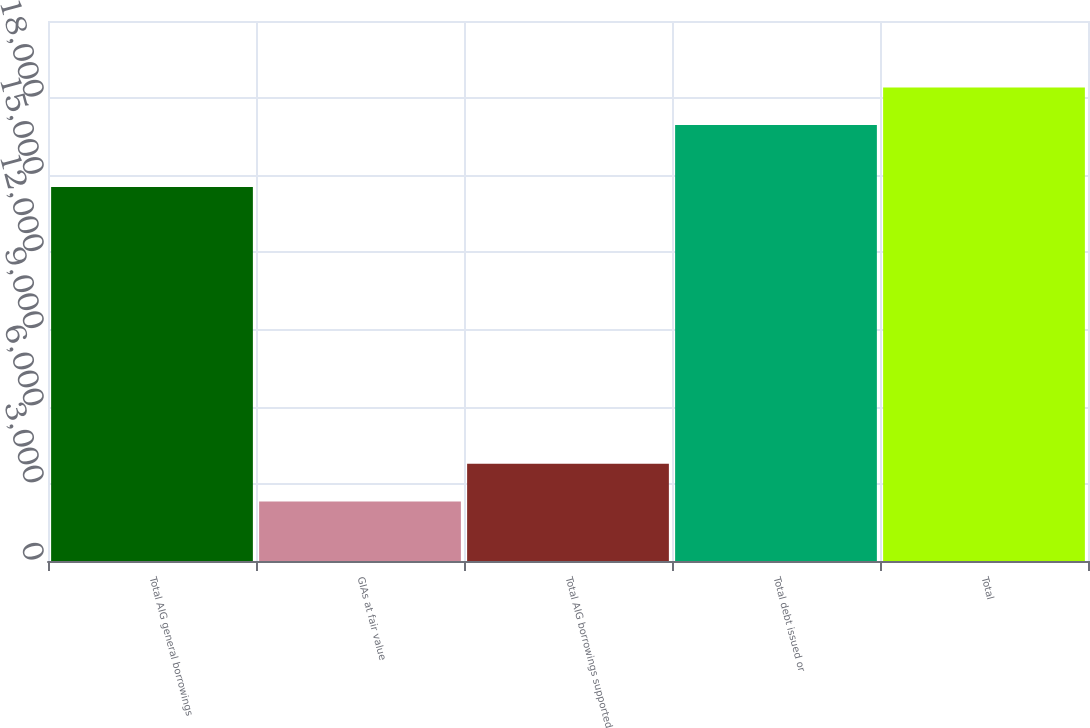Convert chart to OTSL. <chart><loc_0><loc_0><loc_500><loc_500><bar_chart><fcel>Total AIG general borrowings<fcel>GIAs at fair value<fcel>Total AIG borrowings supported<fcel>Total debt issued or<fcel>Total<nl><fcel>14545<fcel>2315<fcel>3778.8<fcel>16953<fcel>18416.8<nl></chart> 